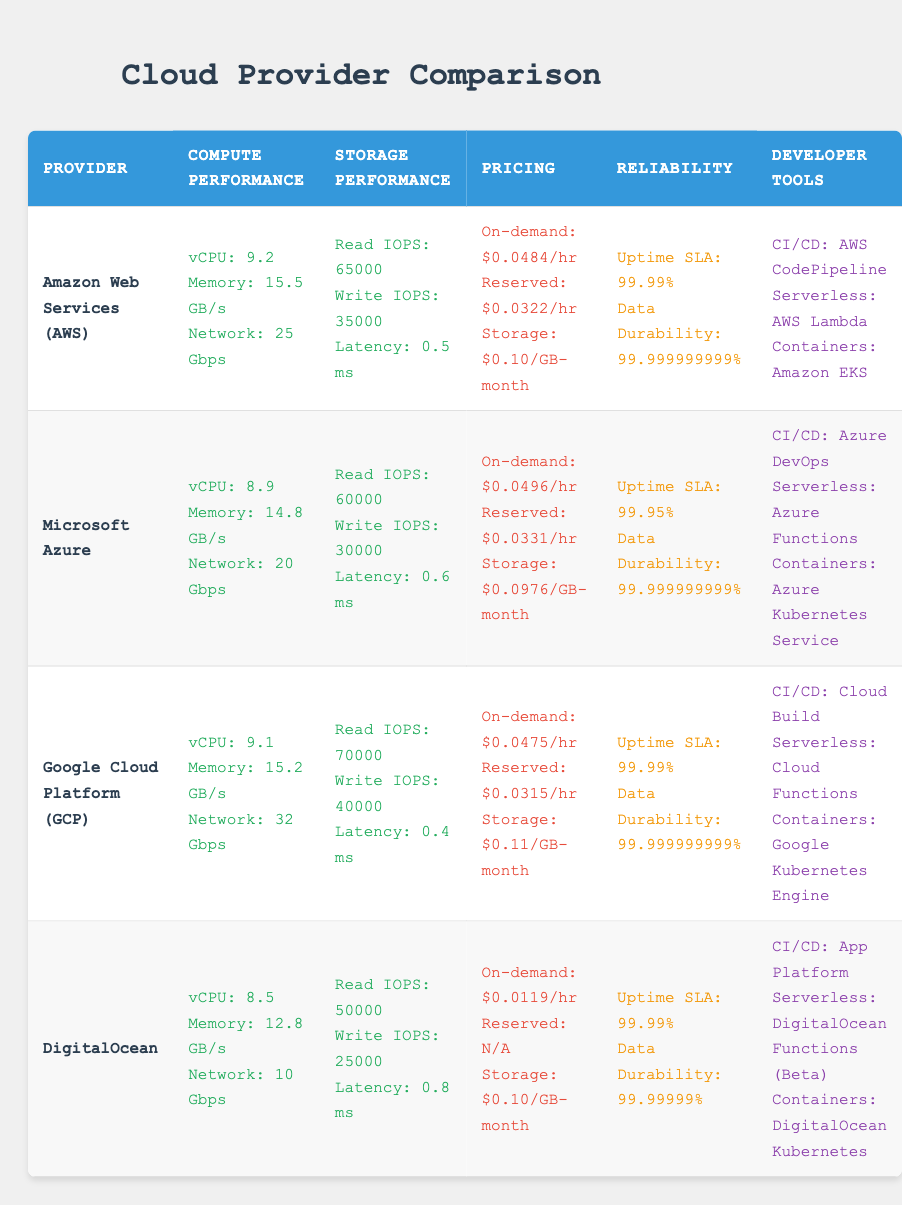What is the network throughput for Google Cloud Platform? The table lists the network throughput for Google Cloud Platform as 32 Gbps under the Compute Performance section.
Answer: 32 Gbps Which cloud provider offers the highest read IOPS performance? To determine the highest read IOPS, we compare the values from the Storage Performance section for each provider: AWS (65000), Azure (60000), GCP (70000), and DigitalOcean (50000). The highest value is 70000 for Google Cloud Platform.
Answer: Google Cloud Platform Is the storage price for DigitalOcean lower than that of AWS? DigitalOcean's storage price is $0.10 per GB-month, while AWS's is also $0.10 per GB-month. Since both prices are equal, the answer is no.
Answer: No What is the average vCPU performance among all four providers? We sum the vCPU performances for each provider: AWS (9.2) + Azure (8.9) + GCP (9.1) + DigitalOcean (8.5) = 35.7. There are 4 providers, so the average is 35.7/4 = 8.925.
Answer: 8.925 Does Microsoft Azure have better memory bandwidth than DigitalOcean? The memory bandwidth for Microsoft Azure is 14.8 GB/s and for DigitalOcean is 12.8 GB/s. Since 14.8 GB/s is greater than 12.8 GB/s, the answer is yes.
Answer: Yes What is the difference in uptime SLA between AWS and Azure? The uptime SLA for AWS is 99.99% and for Azure is 99.95%. To find the difference, we subtract Azure's SLA from AWS's: 99.99% - 99.95% = 0.04%.
Answer: 0.04% Which provider offers the best write IOPS performance? The write IOPS values are: AWS (35000), Azure (30000), GCP (40000), and DigitalOcean (25000). The best performance is 40000 from Google Cloud Platform.
Answer: Google Cloud Platform Is the price for on-demand compute the same for AWS and GCP? AWS's on-demand compute price is $0.0484 per hour while GCP's is $0.0475 per hour. Since these prices differ, the answer is no.
Answer: No What can be concluded about the reliability between the cloud providers based on their data durability? The data durability for AWS, Azure, GCP, and DigitalOcean are all extremely high, with AWS, Azure, and GCP at 99.999999999% and DigitalOcean at 99.99999%. Therefore, AWS, Azure, and GCP have a slightly better data durability rating than DigitalOcean.
Answer: AWS, Azure, and GCP are higher 